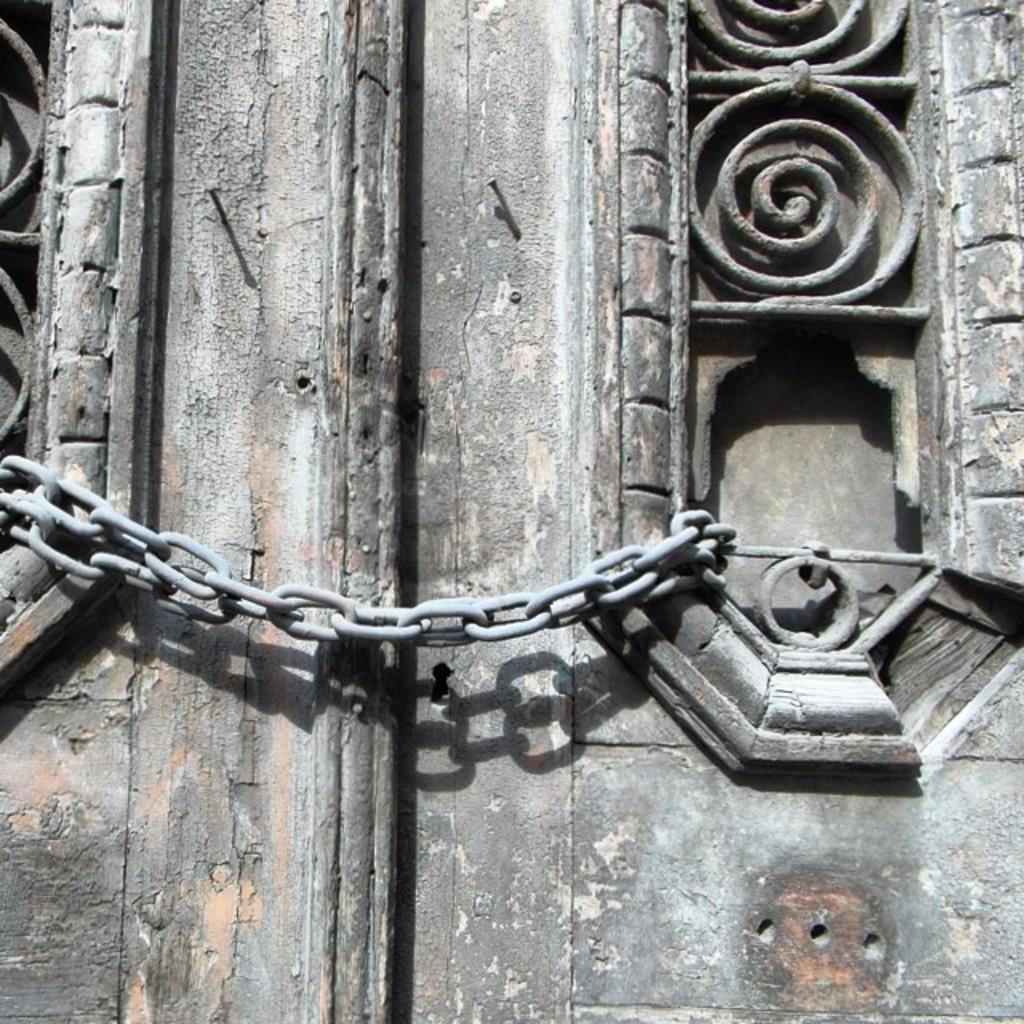Can you describe this image briefly? In this image I can see an iron chain, few Iron nails and shadows. 